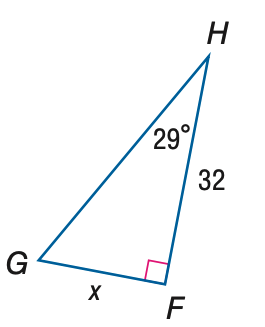Answer the mathemtical geometry problem and directly provide the correct option letter.
Question: Find x. Round to the nearest tenth.
Choices: A: 17.7 B: 36.6 C: 57.7 D: 66.0 A 